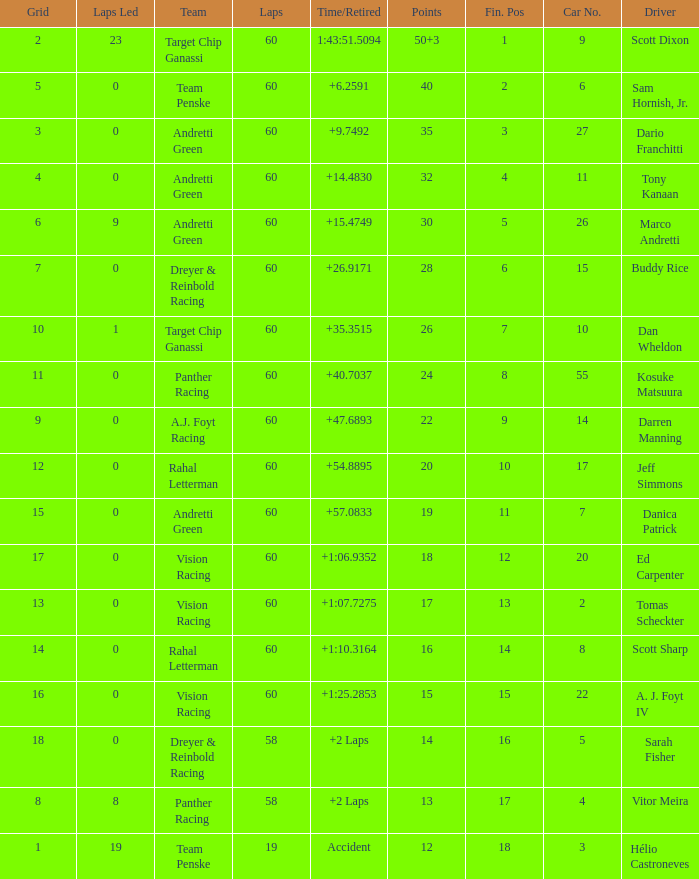What is the total count of grids in a 30-grid system? 1.0. 